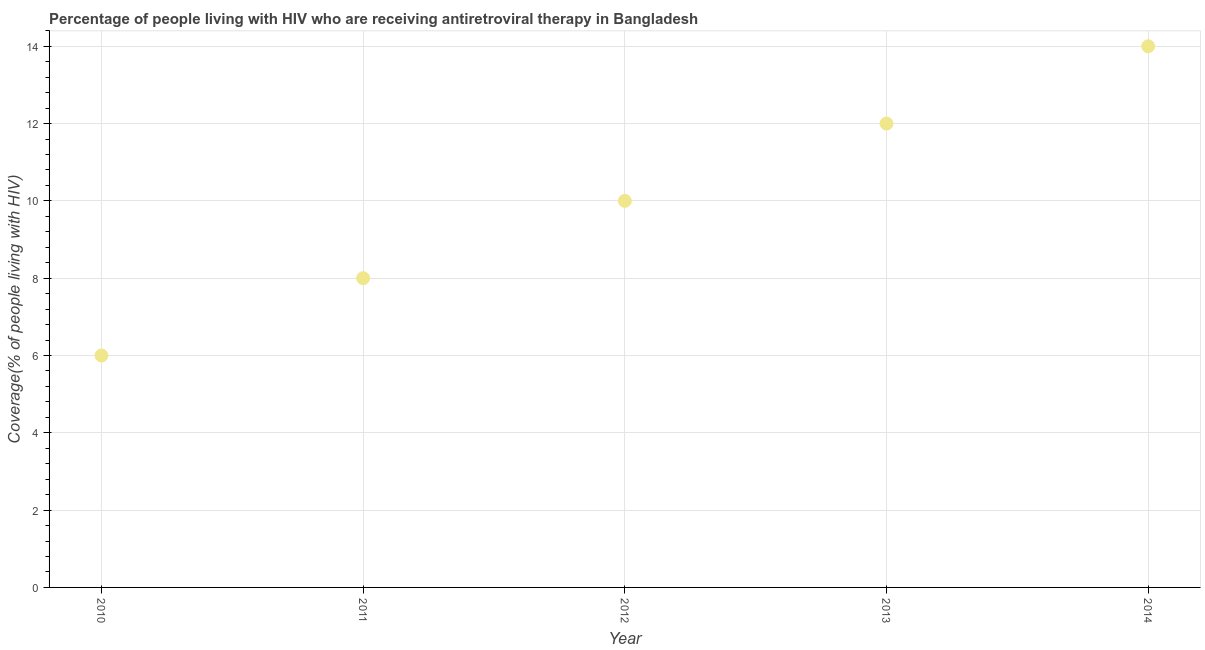What is the antiretroviral therapy coverage in 2011?
Offer a very short reply. 8. Across all years, what is the maximum antiretroviral therapy coverage?
Ensure brevity in your answer.  14. What is the sum of the antiretroviral therapy coverage?
Provide a succinct answer. 50. What is the difference between the antiretroviral therapy coverage in 2011 and 2013?
Ensure brevity in your answer.  -4. What is the average antiretroviral therapy coverage per year?
Make the answer very short. 10. What is the median antiretroviral therapy coverage?
Offer a terse response. 10. Do a majority of the years between 2011 and 2012 (inclusive) have antiretroviral therapy coverage greater than 4.4 %?
Offer a terse response. Yes. What is the ratio of the antiretroviral therapy coverage in 2013 to that in 2014?
Offer a terse response. 0.86. Is the antiretroviral therapy coverage in 2010 less than that in 2013?
Offer a very short reply. Yes. Is the sum of the antiretroviral therapy coverage in 2010 and 2013 greater than the maximum antiretroviral therapy coverage across all years?
Keep it short and to the point. Yes. What is the difference between the highest and the lowest antiretroviral therapy coverage?
Give a very brief answer. 8. How many years are there in the graph?
Your answer should be compact. 5. What is the difference between two consecutive major ticks on the Y-axis?
Give a very brief answer. 2. What is the title of the graph?
Provide a short and direct response. Percentage of people living with HIV who are receiving antiretroviral therapy in Bangladesh. What is the label or title of the Y-axis?
Keep it short and to the point. Coverage(% of people living with HIV). What is the Coverage(% of people living with HIV) in 2010?
Provide a short and direct response. 6. What is the difference between the Coverage(% of people living with HIV) in 2010 and 2011?
Provide a succinct answer. -2. What is the difference between the Coverage(% of people living with HIV) in 2010 and 2013?
Provide a succinct answer. -6. What is the difference between the Coverage(% of people living with HIV) in 2010 and 2014?
Your answer should be compact. -8. What is the difference between the Coverage(% of people living with HIV) in 2011 and 2012?
Provide a succinct answer. -2. What is the difference between the Coverage(% of people living with HIV) in 2012 and 2014?
Your answer should be very brief. -4. What is the difference between the Coverage(% of people living with HIV) in 2013 and 2014?
Your answer should be compact. -2. What is the ratio of the Coverage(% of people living with HIV) in 2010 to that in 2013?
Offer a terse response. 0.5. What is the ratio of the Coverage(% of people living with HIV) in 2010 to that in 2014?
Offer a terse response. 0.43. What is the ratio of the Coverage(% of people living with HIV) in 2011 to that in 2012?
Provide a succinct answer. 0.8. What is the ratio of the Coverage(% of people living with HIV) in 2011 to that in 2013?
Ensure brevity in your answer.  0.67. What is the ratio of the Coverage(% of people living with HIV) in 2011 to that in 2014?
Your response must be concise. 0.57. What is the ratio of the Coverage(% of people living with HIV) in 2012 to that in 2013?
Make the answer very short. 0.83. What is the ratio of the Coverage(% of people living with HIV) in 2012 to that in 2014?
Ensure brevity in your answer.  0.71. What is the ratio of the Coverage(% of people living with HIV) in 2013 to that in 2014?
Provide a short and direct response. 0.86. 